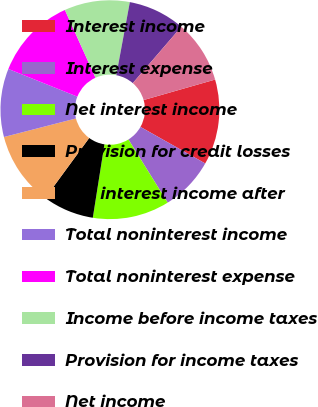Convert chart. <chart><loc_0><loc_0><loc_500><loc_500><pie_chart><fcel>Interest income<fcel>Interest expense<fcel>Net interest income<fcel>Provision for credit losses<fcel>Net interest income after<fcel>Total noninterest income<fcel>Total noninterest expense<fcel>Income before income taxes<fcel>Provision for income taxes<fcel>Net income<nl><fcel>12.61%<fcel>7.98%<fcel>11.34%<fcel>7.56%<fcel>10.92%<fcel>10.08%<fcel>12.18%<fcel>9.66%<fcel>8.4%<fcel>9.24%<nl></chart> 